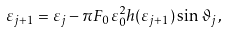Convert formula to latex. <formula><loc_0><loc_0><loc_500><loc_500>\varepsilon _ { j + 1 } = \varepsilon _ { j } - \pi F _ { 0 } \varepsilon _ { 0 } ^ { 2 } h ( \varepsilon _ { j + 1 } ) \sin \vartheta _ { j } \, ,</formula> 